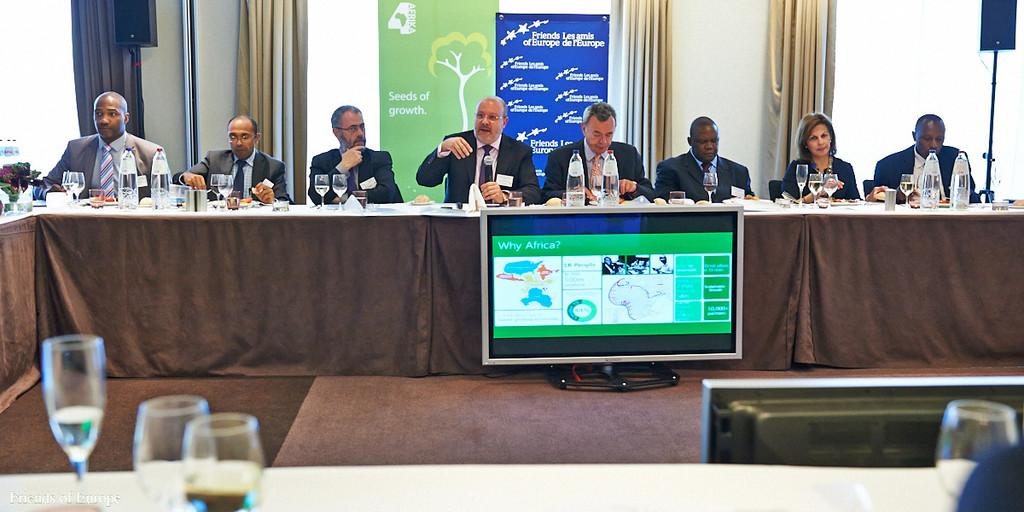<image>
Write a terse but informative summary of the picture. Large computer monitor that says "Why Africa?" in front of a group of people having a meeting. 